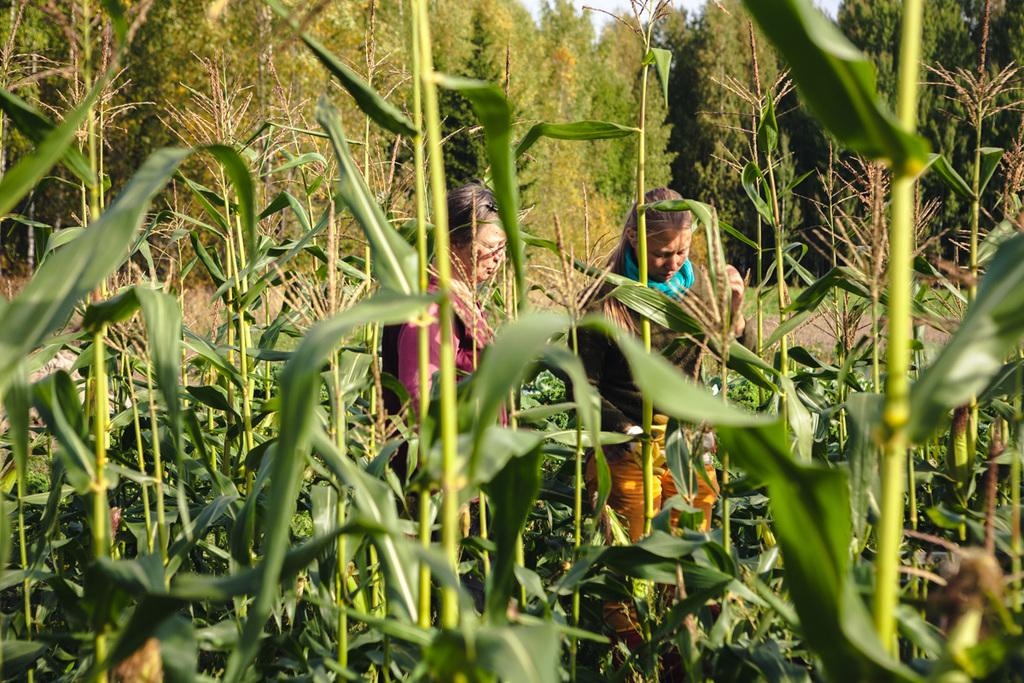How many women are present in the image? There are two women standing on the ground in the image. What type of plants can be seen in the image? There are corn plants in the image. What can be seen in the background of the image? There are trees visible in the background of the image. What type of beast is visible in the image? There is no beast present in the image. What part of the body is shown in the image? The image does not show any specific body part; it features two women standing on the ground and corn plants. 